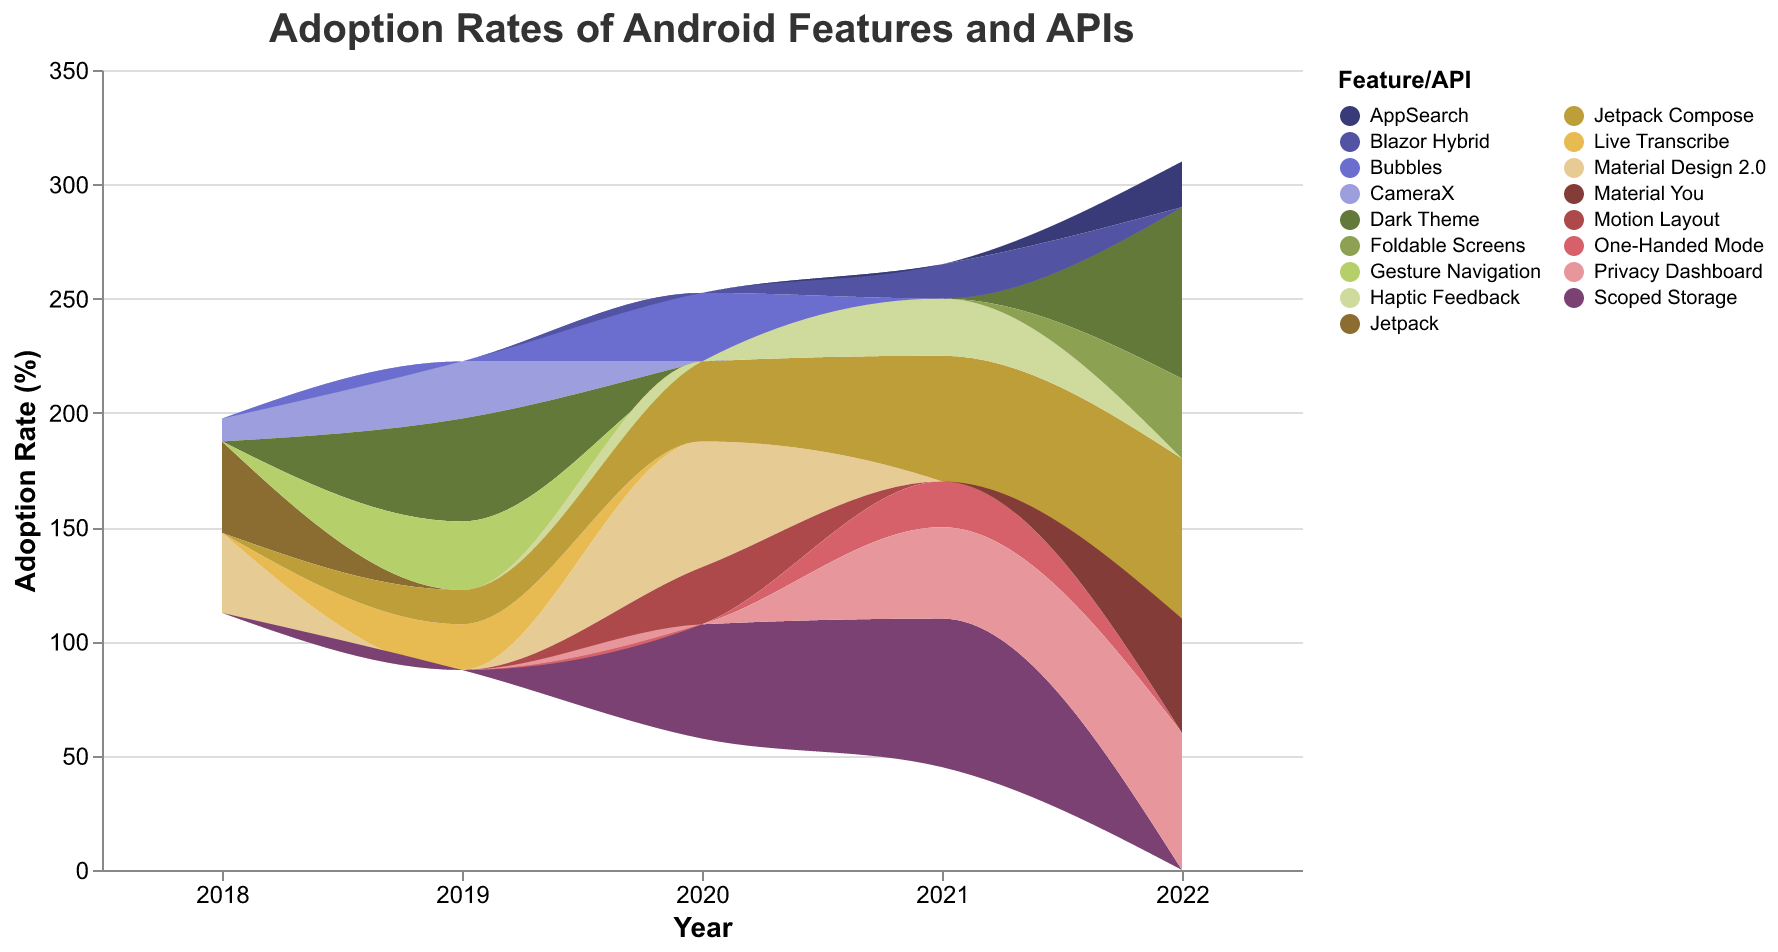Which Android feature had the highest adoption rate in 2022? To find this, we look at the stack height at the year 2022 and identify which feature/API contributed the most. The 'Dark Theme' had an adoption rate of 75%.
Answer: Dark Theme How much did the adoption rate of Jetpack Compose increase from 2019 to 2022? In 2019, the adoption rate was 15%. By 2022, it increased to 70%. The increase is calculated as 70% - 15% = 55%.
Answer: 55% Which year saw the highest adoption rate for Scoped Storage? We need to find the highest point of 'Scoped Storage' across the years. In 2021, Scoped Storage had a 65% adoption rate.
Answer: 2021 How did the adoption rate of Material Design 2.0 change from 2018 to 2020? In 2018, the adoption rate was 35%. In 2020, it increased to 55%. So, the change is 55% - 35% = 20%.
Answer: Increased by 20% What was the adoption trend for Jetpack Compose between 2019 and 2022? Observing the layers for Jetpack Compose, it starts at 15% in 2019, increases to 35% in 2020, 55% in 2021, and peaks at 70% in 2022. The trend shows a continuous increase.
Answer: Increasing Which feature/API had an adoption rate of 40% in both 2018 and 2021? By examining the layers, 'Jetpack' had an adoption rate of 40% in 2018, and 'Privacy Dashboard' had an adoption rate of 40% in 2021.
Answer: Jetpack and Privacy Dashboard What is the total adoption rate of new features introduced in 2019? The new features in 2019 are 'Dark Theme' (45%), 'Gesture Navigation' (30%), 'Live Transcribe' (20%). Their total adoption rate is 45% + 30% + 20% = 95%.
Answer: 95% Which features maintained a growing adoption rate from their introduction until 2022? Features such as 'Jetpack Compose' (introduced in 2019 with increasing adoption yearly) and 'Privacy Dashboard' (introduced in 2021) maintained growing adoption rates.
Answer: Jetpack Compose, Privacy Dashboard Compare the adoption rate of Dark Theme in its introduction year with its rate in 2022. Dark Theme was introduced in 2019 with a 45% adoption rate. By 2022, its adoption rate grew to 75%. The increase is 75% - 45% = 30%.
Answer: 30% increase What feature introduced in 2022 had the lowest adoption rate? From the 2022 introduction list: Material You (50%), Foldable Screens (35%), Privacy Dashboard (60%), AppSearch (20%), AppSearch had the lowest adoption rate at 20%.
Answer: AppSearch 